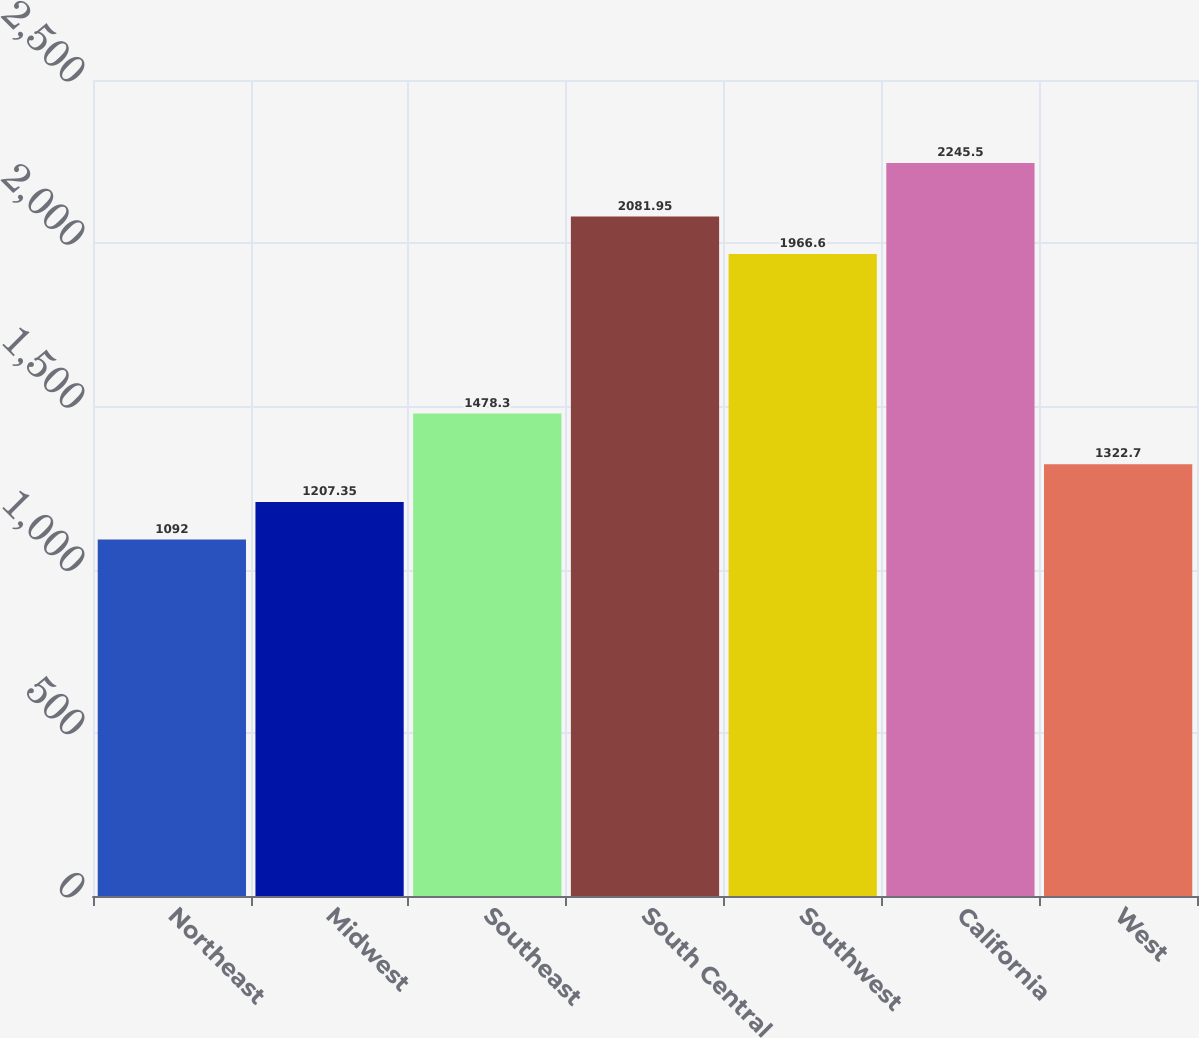Convert chart. <chart><loc_0><loc_0><loc_500><loc_500><bar_chart><fcel>Northeast<fcel>Midwest<fcel>Southeast<fcel>South Central<fcel>Southwest<fcel>California<fcel>West<nl><fcel>1092<fcel>1207.35<fcel>1478.3<fcel>2081.95<fcel>1966.6<fcel>2245.5<fcel>1322.7<nl></chart> 